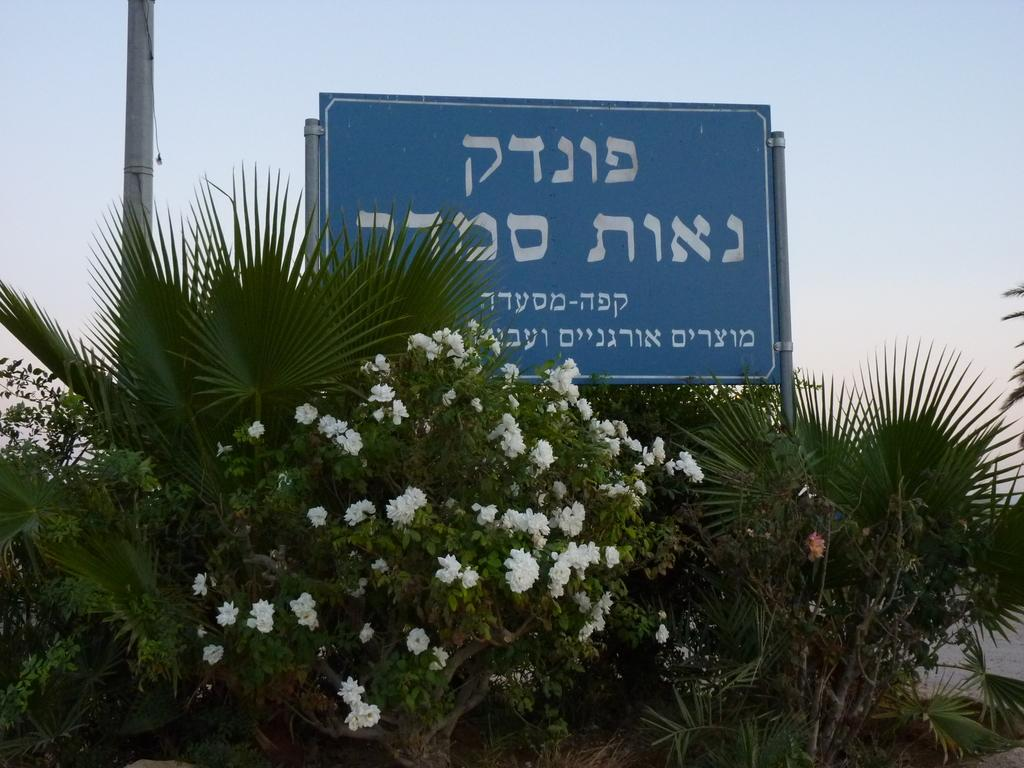What type of plant is in the image? There is a plant in the image, and it has white flowers. What color is the board in the image? The board in the image is blue. What is written on the board? The board has white text on it. What other object can be seen in the image? There is a pole in the image. What can be seen in the background of the image? The sky is visible in the image. How many clocks are present in the image? There are no clocks present in the image. What causes the plant to sneeze in the image? Plants do not have the ability to sneeze, so this action cannot be observed in the image. 